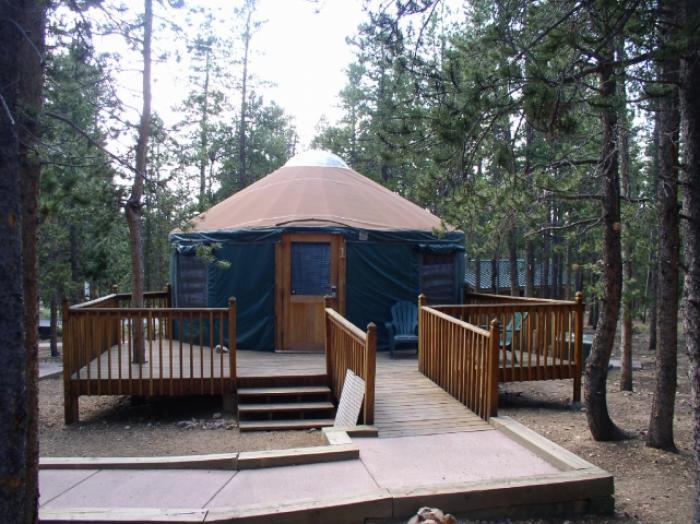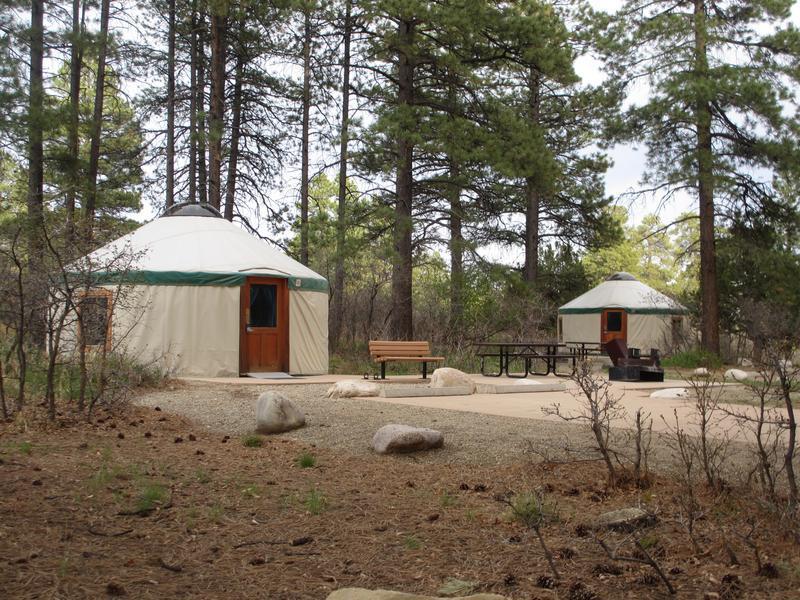The first image is the image on the left, the second image is the image on the right. Examine the images to the left and right. Is the description "There is a structure with a wooden roof to the right of the yurt in the image on the right." accurate? Answer yes or no. No. 